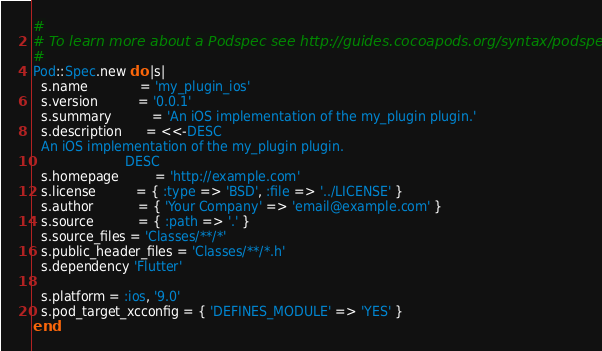<code> <loc_0><loc_0><loc_500><loc_500><_Ruby_>#
# To learn more about a Podspec see http://guides.cocoapods.org/syntax/podspec.html
#
Pod::Spec.new do |s|
  s.name             = 'my_plugin_ios'
  s.version          = '0.0.1'
  s.summary          = 'An iOS implementation of the my_plugin plugin.'
  s.description      = <<-DESC
  An iOS implementation of the my_plugin plugin.
                       DESC
  s.homepage         = 'http://example.com'
  s.license          = { :type => 'BSD', :file => '../LICENSE' }
  s.author           = { 'Your Company' => 'email@example.com' }
  s.source           = { :path => '.' }  
  s.source_files = 'Classes/**/*'
  s.public_header_files = 'Classes/**/*.h'
  s.dependency 'Flutter'

  s.platform = :ios, '9.0'
  s.pod_target_xcconfig = { 'DEFINES_MODULE' => 'YES' }  
end
</code> 